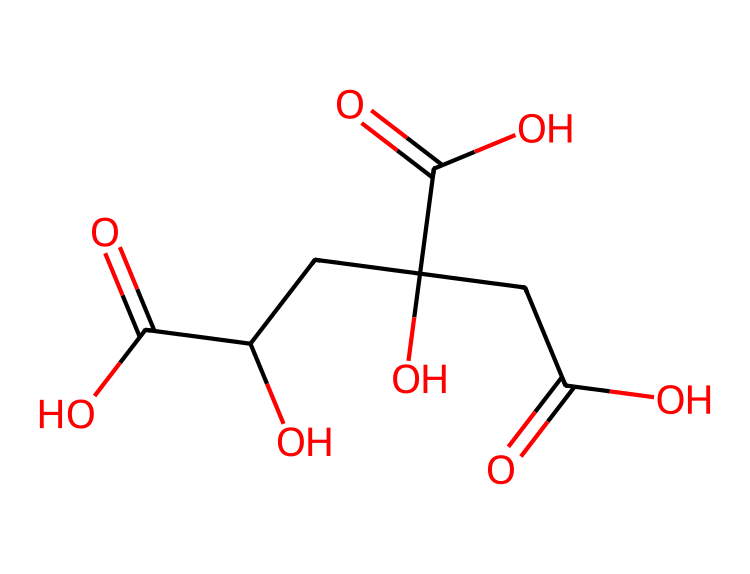What is the total number of carbon atoms in citric acid? The SMILES representation includes three carbon chains connected, each contributing to the total number of carbon atoms. Counting them gives a total of six carbon atoms.
Answer: six How many hydroxyl (-OH) groups are present in citric acid? The structure reveals three -OH groups, where each corresponds to a single hydroxyl group attached to a carbon atom.
Answer: three What category of acids does citric acid belong to? Citric acid is a carboxylic acid, indicated by the presence of multiple carboxyl (-COOH) groups in its structure.
Answer: carboxylic acid What is the pH level range for citric acid? Citric acid typically has a pH range around 2 to 3 in solution, which indicates its acidic nature.
Answer: 2 to 3 How many carboxyl (-COOH) groups are in citric acid? By analyzing the SMILES, there are three instances of the -COOH functional group that contribute to its properties as an acid.
Answer: three What impact do the hydroxyl groups have on citric acid's solubility? The presence of hydroxyl groups enhances the solubility of citric acid in water due to their ability to form hydrogen bonds with water molecules.
Answer: enhanced solubility How does citric acid influence energy drinks? Citric acid acts as a flavoring and preservative in energy drinks, balancing taste and preventing spoilage through its acidity.
Answer: flavoring and preservative 